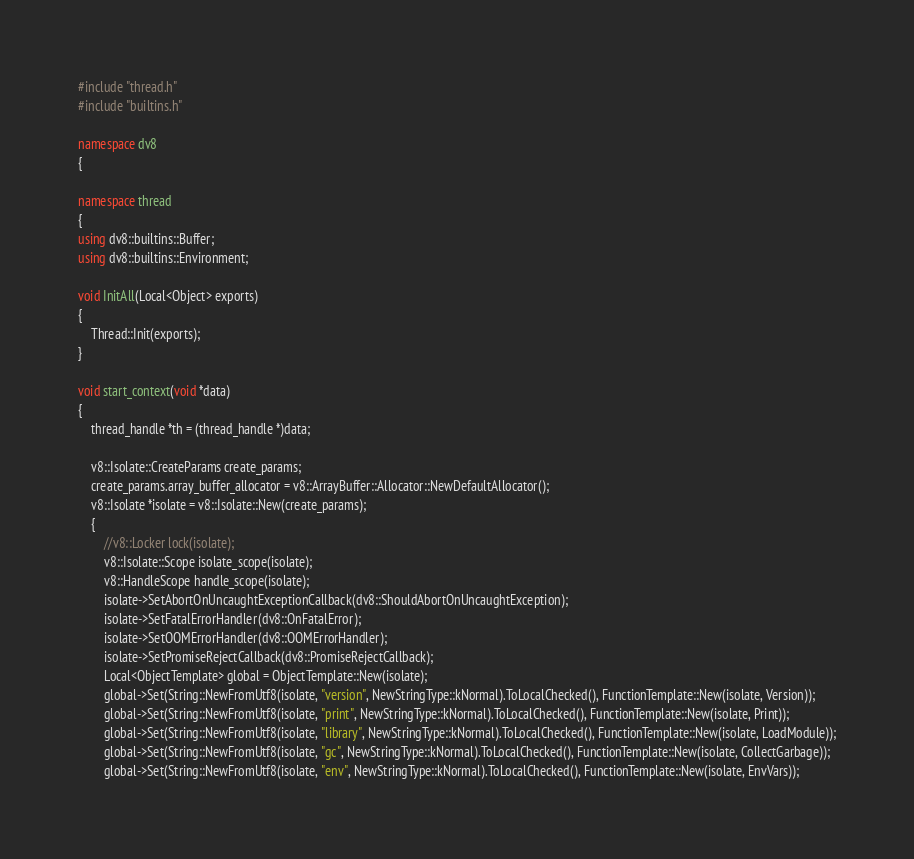<code> <loc_0><loc_0><loc_500><loc_500><_C++_>#include "thread.h"
#include "builtins.h"

namespace dv8
{

namespace thread
{
using dv8::builtins::Buffer;
using dv8::builtins::Environment;

void InitAll(Local<Object> exports)
{
	Thread::Init(exports);
}

void start_context(void *data)
{
	thread_handle *th = (thread_handle *)data;

	v8::Isolate::CreateParams create_params;
	create_params.array_buffer_allocator = v8::ArrayBuffer::Allocator::NewDefaultAllocator();
	v8::Isolate *isolate = v8::Isolate::New(create_params);
	{
		//v8::Locker lock(isolate);
		v8::Isolate::Scope isolate_scope(isolate);
		v8::HandleScope handle_scope(isolate);
		isolate->SetAbortOnUncaughtExceptionCallback(dv8::ShouldAbortOnUncaughtException);
		isolate->SetFatalErrorHandler(dv8::OnFatalError);
		isolate->SetOOMErrorHandler(dv8::OOMErrorHandler);
		isolate->SetPromiseRejectCallback(dv8::PromiseRejectCallback);
		Local<ObjectTemplate> global = ObjectTemplate::New(isolate);
		global->Set(String::NewFromUtf8(isolate, "version", NewStringType::kNormal).ToLocalChecked(), FunctionTemplate::New(isolate, Version));
		global->Set(String::NewFromUtf8(isolate, "print", NewStringType::kNormal).ToLocalChecked(), FunctionTemplate::New(isolate, Print));
		global->Set(String::NewFromUtf8(isolate, "library", NewStringType::kNormal).ToLocalChecked(), FunctionTemplate::New(isolate, LoadModule));
		global->Set(String::NewFromUtf8(isolate, "gc", NewStringType::kNormal).ToLocalChecked(), FunctionTemplate::New(isolate, CollectGarbage));
		global->Set(String::NewFromUtf8(isolate, "env", NewStringType::kNormal).ToLocalChecked(), FunctionTemplate::New(isolate, EnvVars));</code> 